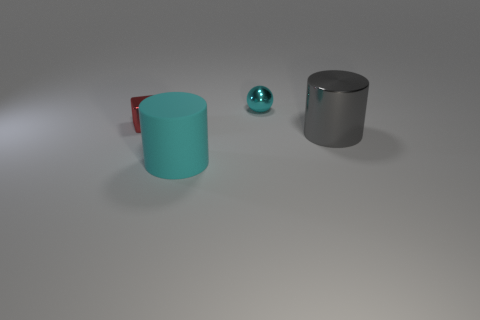Do the shiny ball and the large cylinder that is to the left of the cyan metallic ball have the same color?
Keep it short and to the point. Yes. What is the size of the shiny ball that is the same color as the big matte cylinder?
Ensure brevity in your answer.  Small. What is the material of the thing that is the same color as the tiny shiny ball?
Provide a short and direct response. Rubber. What size is the metallic thing that is on the left side of the large gray cylinder and to the right of the small red cube?
Provide a short and direct response. Small. The tiny object to the right of the tiny thing in front of the tiny thing behind the tiny red metal object is made of what material?
Make the answer very short. Metal. What number of metal objects are cyan cylinders or large blue objects?
Make the answer very short. 0. Are there any large matte cylinders?
Your answer should be compact. Yes. There is a tiny metallic object in front of the tiny metal thing that is behind the small red shiny block; what color is it?
Provide a short and direct response. Red. How many other objects are there of the same color as the rubber cylinder?
Make the answer very short. 1. What number of objects are either gray shiny cylinders or small things that are in front of the tiny cyan thing?
Make the answer very short. 2. 